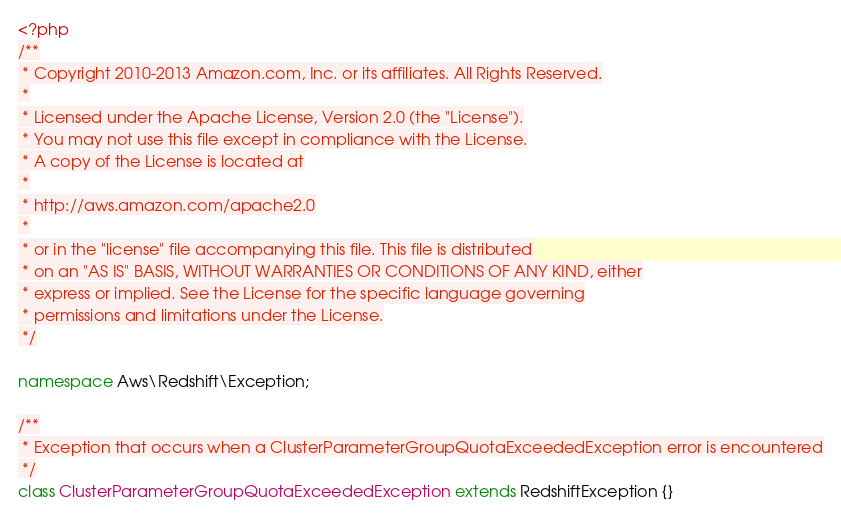Convert code to text. <code><loc_0><loc_0><loc_500><loc_500><_PHP_><?php
/**
 * Copyright 2010-2013 Amazon.com, Inc. or its affiliates. All Rights Reserved.
 *
 * Licensed under the Apache License, Version 2.0 (the "License").
 * You may not use this file except in compliance with the License.
 * A copy of the License is located at
 *
 * http://aws.amazon.com/apache2.0
 *
 * or in the "license" file accompanying this file. This file is distributed
 * on an "AS IS" BASIS, WITHOUT WARRANTIES OR CONDITIONS OF ANY KIND, either
 * express or implied. See the License for the specific language governing
 * permissions and limitations under the License.
 */

namespace Aws\Redshift\Exception;

/**
 * Exception that occurs when a ClusterParameterGroupQuotaExceededException error is encountered
 */
class ClusterParameterGroupQuotaExceededException extends RedshiftException {}
</code> 